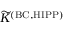Convert formula to latex. <formula><loc_0><loc_0><loc_500><loc_500>\widetilde { K } ^ { ( B C , H I P P ) }</formula> 